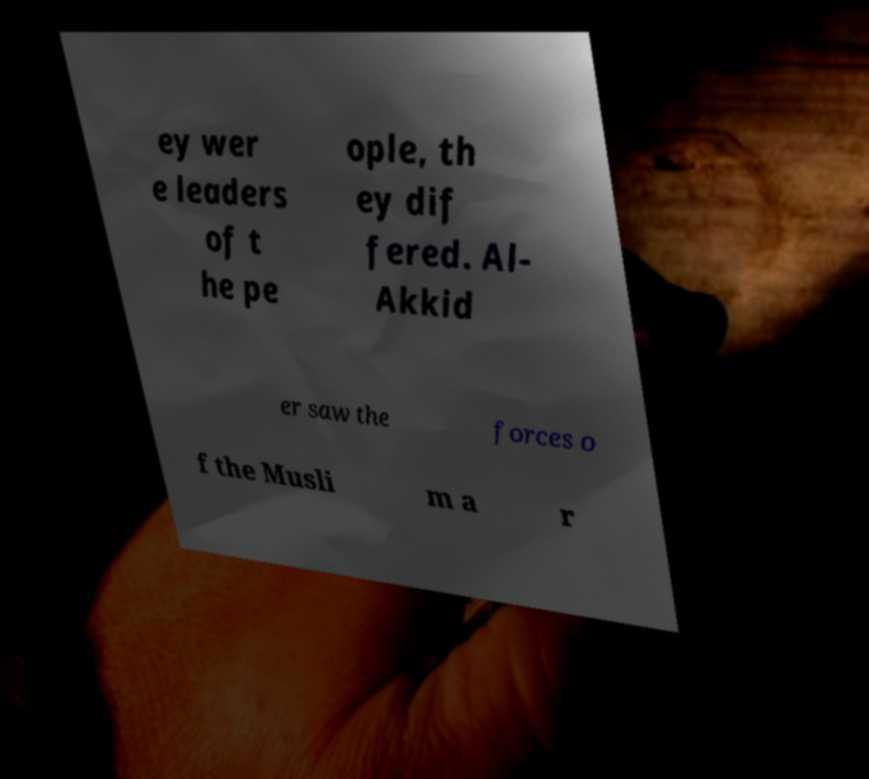Please read and relay the text visible in this image. What does it say? ey wer e leaders of t he pe ople, th ey dif fered. Al- Akkid er saw the forces o f the Musli m a r 